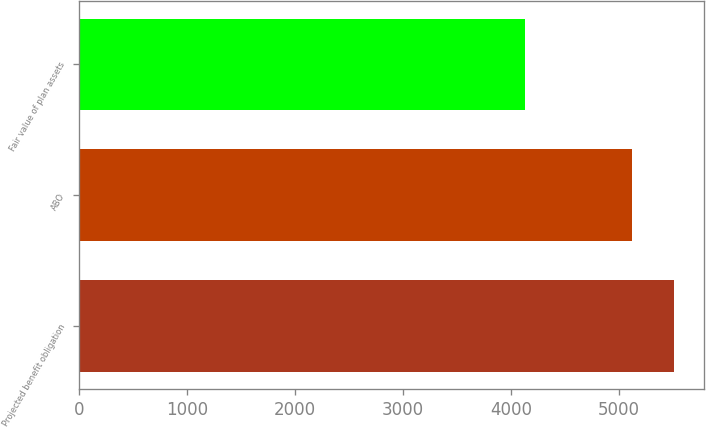Convert chart to OTSL. <chart><loc_0><loc_0><loc_500><loc_500><bar_chart><fcel>Projected benefit obligation<fcel>ABO<fcel>Fair value of plan assets<nl><fcel>5509.2<fcel>5119.6<fcel>4126.2<nl></chart> 